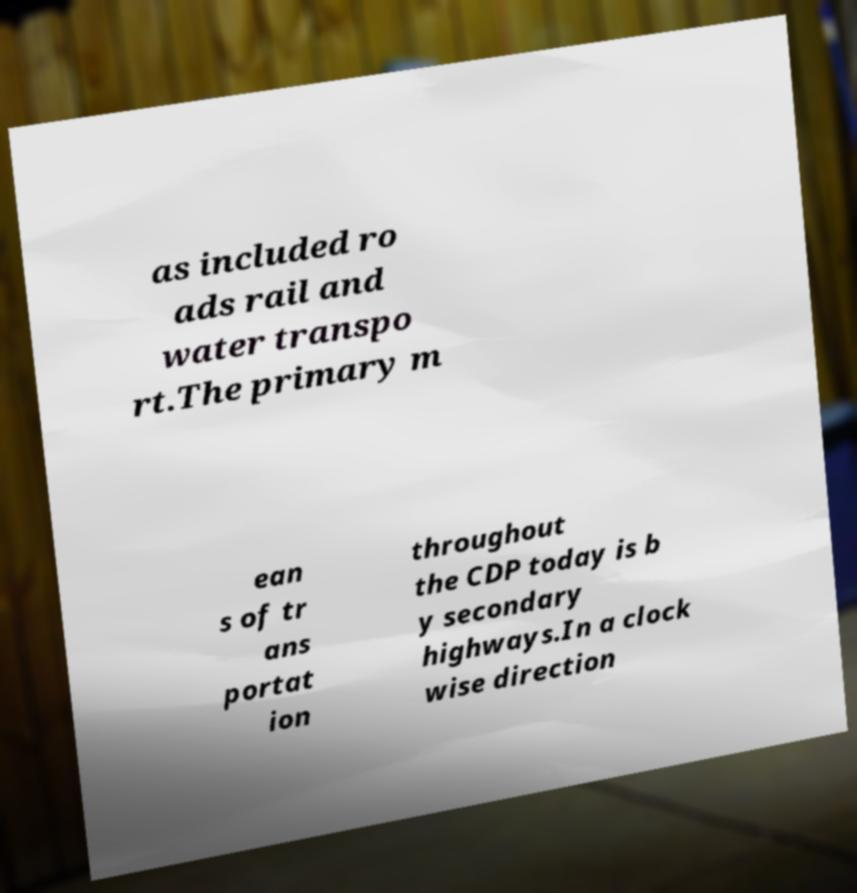What messages or text are displayed in this image? I need them in a readable, typed format. as included ro ads rail and water transpo rt.The primary m ean s of tr ans portat ion throughout the CDP today is b y secondary highways.In a clock wise direction 